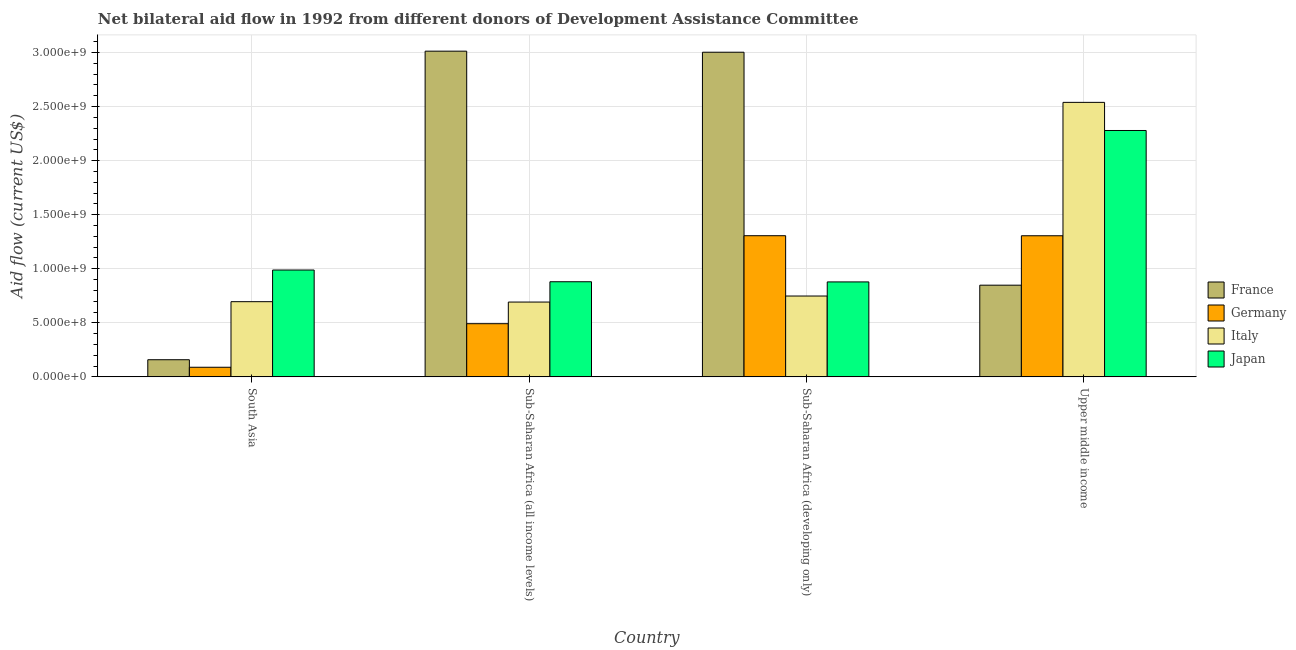How many different coloured bars are there?
Ensure brevity in your answer.  4. How many groups of bars are there?
Your response must be concise. 4. How many bars are there on the 3rd tick from the left?
Provide a short and direct response. 4. What is the label of the 2nd group of bars from the left?
Ensure brevity in your answer.  Sub-Saharan Africa (all income levels). What is the amount of aid given by italy in Sub-Saharan Africa (all income levels)?
Provide a short and direct response. 6.92e+08. Across all countries, what is the maximum amount of aid given by italy?
Offer a terse response. 2.54e+09. Across all countries, what is the minimum amount of aid given by germany?
Your answer should be compact. 8.89e+07. In which country was the amount of aid given by germany maximum?
Give a very brief answer. Sub-Saharan Africa (developing only). In which country was the amount of aid given by japan minimum?
Make the answer very short. Sub-Saharan Africa (developing only). What is the total amount of aid given by japan in the graph?
Offer a terse response. 5.03e+09. What is the difference between the amount of aid given by italy in Sub-Saharan Africa (all income levels) and that in Upper middle income?
Provide a short and direct response. -1.85e+09. What is the difference between the amount of aid given by germany in Upper middle income and the amount of aid given by france in South Asia?
Provide a succinct answer. 1.15e+09. What is the average amount of aid given by france per country?
Your response must be concise. 1.76e+09. What is the difference between the amount of aid given by italy and amount of aid given by france in Sub-Saharan Africa (all income levels)?
Keep it short and to the point. -2.32e+09. In how many countries, is the amount of aid given by italy greater than 2800000000 US$?
Provide a short and direct response. 0. What is the ratio of the amount of aid given by france in Sub-Saharan Africa (developing only) to that in Upper middle income?
Keep it short and to the point. 3.54. Is the amount of aid given by italy in Sub-Saharan Africa (all income levels) less than that in Upper middle income?
Provide a short and direct response. Yes. Is the difference between the amount of aid given by germany in Sub-Saharan Africa (developing only) and Upper middle income greater than the difference between the amount of aid given by italy in Sub-Saharan Africa (developing only) and Upper middle income?
Provide a succinct answer. Yes. What is the difference between the highest and the second highest amount of aid given by japan?
Give a very brief answer. 1.29e+09. What is the difference between the highest and the lowest amount of aid given by germany?
Ensure brevity in your answer.  1.22e+09. In how many countries, is the amount of aid given by japan greater than the average amount of aid given by japan taken over all countries?
Ensure brevity in your answer.  1. What does the 2nd bar from the right in Upper middle income represents?
Provide a succinct answer. Italy. Is it the case that in every country, the sum of the amount of aid given by france and amount of aid given by germany is greater than the amount of aid given by italy?
Offer a very short reply. No. How many bars are there?
Make the answer very short. 16. Are all the bars in the graph horizontal?
Offer a very short reply. No. What is the difference between two consecutive major ticks on the Y-axis?
Offer a very short reply. 5.00e+08. Are the values on the major ticks of Y-axis written in scientific E-notation?
Ensure brevity in your answer.  Yes. Does the graph contain grids?
Your response must be concise. Yes. How many legend labels are there?
Your answer should be compact. 4. What is the title of the graph?
Your response must be concise. Net bilateral aid flow in 1992 from different donors of Development Assistance Committee. Does "Primary" appear as one of the legend labels in the graph?
Your answer should be very brief. No. What is the label or title of the X-axis?
Provide a short and direct response. Country. What is the Aid flow (current US$) in France in South Asia?
Give a very brief answer. 1.59e+08. What is the Aid flow (current US$) in Germany in South Asia?
Provide a succinct answer. 8.89e+07. What is the Aid flow (current US$) of Italy in South Asia?
Make the answer very short. 6.95e+08. What is the Aid flow (current US$) in Japan in South Asia?
Ensure brevity in your answer.  9.88e+08. What is the Aid flow (current US$) of France in Sub-Saharan Africa (all income levels)?
Offer a terse response. 3.01e+09. What is the Aid flow (current US$) of Germany in Sub-Saharan Africa (all income levels)?
Provide a succinct answer. 4.92e+08. What is the Aid flow (current US$) in Italy in Sub-Saharan Africa (all income levels)?
Your answer should be compact. 6.92e+08. What is the Aid flow (current US$) in Japan in Sub-Saharan Africa (all income levels)?
Ensure brevity in your answer.  8.80e+08. What is the Aid flow (current US$) of France in Sub-Saharan Africa (developing only)?
Offer a very short reply. 3.00e+09. What is the Aid flow (current US$) of Germany in Sub-Saharan Africa (developing only)?
Give a very brief answer. 1.31e+09. What is the Aid flow (current US$) in Italy in Sub-Saharan Africa (developing only)?
Provide a short and direct response. 7.48e+08. What is the Aid flow (current US$) in Japan in Sub-Saharan Africa (developing only)?
Offer a terse response. 8.78e+08. What is the Aid flow (current US$) in France in Upper middle income?
Provide a succinct answer. 8.48e+08. What is the Aid flow (current US$) in Germany in Upper middle income?
Your answer should be very brief. 1.31e+09. What is the Aid flow (current US$) in Italy in Upper middle income?
Keep it short and to the point. 2.54e+09. What is the Aid flow (current US$) in Japan in Upper middle income?
Give a very brief answer. 2.28e+09. Across all countries, what is the maximum Aid flow (current US$) of France?
Keep it short and to the point. 3.01e+09. Across all countries, what is the maximum Aid flow (current US$) of Germany?
Your answer should be very brief. 1.31e+09. Across all countries, what is the maximum Aid flow (current US$) in Italy?
Ensure brevity in your answer.  2.54e+09. Across all countries, what is the maximum Aid flow (current US$) of Japan?
Provide a short and direct response. 2.28e+09. Across all countries, what is the minimum Aid flow (current US$) of France?
Your answer should be compact. 1.59e+08. Across all countries, what is the minimum Aid flow (current US$) in Germany?
Ensure brevity in your answer.  8.89e+07. Across all countries, what is the minimum Aid flow (current US$) in Italy?
Offer a terse response. 6.92e+08. Across all countries, what is the minimum Aid flow (current US$) in Japan?
Provide a short and direct response. 8.78e+08. What is the total Aid flow (current US$) in France in the graph?
Offer a terse response. 7.02e+09. What is the total Aid flow (current US$) in Germany in the graph?
Ensure brevity in your answer.  3.19e+09. What is the total Aid flow (current US$) in Italy in the graph?
Provide a short and direct response. 4.67e+09. What is the total Aid flow (current US$) of Japan in the graph?
Ensure brevity in your answer.  5.03e+09. What is the difference between the Aid flow (current US$) of France in South Asia and that in Sub-Saharan Africa (all income levels)?
Offer a very short reply. -2.85e+09. What is the difference between the Aid flow (current US$) in Germany in South Asia and that in Sub-Saharan Africa (all income levels)?
Offer a terse response. -4.03e+08. What is the difference between the Aid flow (current US$) in Italy in South Asia and that in Sub-Saharan Africa (all income levels)?
Give a very brief answer. 3.39e+06. What is the difference between the Aid flow (current US$) of Japan in South Asia and that in Sub-Saharan Africa (all income levels)?
Your response must be concise. 1.08e+08. What is the difference between the Aid flow (current US$) of France in South Asia and that in Sub-Saharan Africa (developing only)?
Ensure brevity in your answer.  -2.84e+09. What is the difference between the Aid flow (current US$) in Germany in South Asia and that in Sub-Saharan Africa (developing only)?
Keep it short and to the point. -1.22e+09. What is the difference between the Aid flow (current US$) in Italy in South Asia and that in Sub-Saharan Africa (developing only)?
Ensure brevity in your answer.  -5.24e+07. What is the difference between the Aid flow (current US$) of Japan in South Asia and that in Sub-Saharan Africa (developing only)?
Provide a succinct answer. 1.10e+08. What is the difference between the Aid flow (current US$) of France in South Asia and that in Upper middle income?
Your answer should be very brief. -6.89e+08. What is the difference between the Aid flow (current US$) in Germany in South Asia and that in Upper middle income?
Make the answer very short. -1.22e+09. What is the difference between the Aid flow (current US$) of Italy in South Asia and that in Upper middle income?
Ensure brevity in your answer.  -1.84e+09. What is the difference between the Aid flow (current US$) of Japan in South Asia and that in Upper middle income?
Keep it short and to the point. -1.29e+09. What is the difference between the Aid flow (current US$) of France in Sub-Saharan Africa (all income levels) and that in Sub-Saharan Africa (developing only)?
Offer a terse response. 9.93e+06. What is the difference between the Aid flow (current US$) in Germany in Sub-Saharan Africa (all income levels) and that in Sub-Saharan Africa (developing only)?
Your answer should be compact. -8.14e+08. What is the difference between the Aid flow (current US$) of Italy in Sub-Saharan Africa (all income levels) and that in Sub-Saharan Africa (developing only)?
Ensure brevity in your answer.  -5.58e+07. What is the difference between the Aid flow (current US$) of Japan in Sub-Saharan Africa (all income levels) and that in Sub-Saharan Africa (developing only)?
Give a very brief answer. 1.49e+06. What is the difference between the Aid flow (current US$) in France in Sub-Saharan Africa (all income levels) and that in Upper middle income?
Your response must be concise. 2.16e+09. What is the difference between the Aid flow (current US$) of Germany in Sub-Saharan Africa (all income levels) and that in Upper middle income?
Give a very brief answer. -8.13e+08. What is the difference between the Aid flow (current US$) of Italy in Sub-Saharan Africa (all income levels) and that in Upper middle income?
Offer a very short reply. -1.85e+09. What is the difference between the Aid flow (current US$) of Japan in Sub-Saharan Africa (all income levels) and that in Upper middle income?
Make the answer very short. -1.40e+09. What is the difference between the Aid flow (current US$) in France in Sub-Saharan Africa (developing only) and that in Upper middle income?
Ensure brevity in your answer.  2.15e+09. What is the difference between the Aid flow (current US$) in Italy in Sub-Saharan Africa (developing only) and that in Upper middle income?
Make the answer very short. -1.79e+09. What is the difference between the Aid flow (current US$) in Japan in Sub-Saharan Africa (developing only) and that in Upper middle income?
Keep it short and to the point. -1.40e+09. What is the difference between the Aid flow (current US$) of France in South Asia and the Aid flow (current US$) of Germany in Sub-Saharan Africa (all income levels)?
Provide a short and direct response. -3.33e+08. What is the difference between the Aid flow (current US$) in France in South Asia and the Aid flow (current US$) in Italy in Sub-Saharan Africa (all income levels)?
Ensure brevity in your answer.  -5.33e+08. What is the difference between the Aid flow (current US$) in France in South Asia and the Aid flow (current US$) in Japan in Sub-Saharan Africa (all income levels)?
Give a very brief answer. -7.21e+08. What is the difference between the Aid flow (current US$) in Germany in South Asia and the Aid flow (current US$) in Italy in Sub-Saharan Africa (all income levels)?
Your answer should be very brief. -6.03e+08. What is the difference between the Aid flow (current US$) of Germany in South Asia and the Aid flow (current US$) of Japan in Sub-Saharan Africa (all income levels)?
Make the answer very short. -7.91e+08. What is the difference between the Aid flow (current US$) in Italy in South Asia and the Aid flow (current US$) in Japan in Sub-Saharan Africa (all income levels)?
Provide a short and direct response. -1.84e+08. What is the difference between the Aid flow (current US$) of France in South Asia and the Aid flow (current US$) of Germany in Sub-Saharan Africa (developing only)?
Give a very brief answer. -1.15e+09. What is the difference between the Aid flow (current US$) of France in South Asia and the Aid flow (current US$) of Italy in Sub-Saharan Africa (developing only)?
Provide a succinct answer. -5.89e+08. What is the difference between the Aid flow (current US$) of France in South Asia and the Aid flow (current US$) of Japan in Sub-Saharan Africa (developing only)?
Provide a succinct answer. -7.20e+08. What is the difference between the Aid flow (current US$) of Germany in South Asia and the Aid flow (current US$) of Italy in Sub-Saharan Africa (developing only)?
Ensure brevity in your answer.  -6.59e+08. What is the difference between the Aid flow (current US$) in Germany in South Asia and the Aid flow (current US$) in Japan in Sub-Saharan Africa (developing only)?
Give a very brief answer. -7.90e+08. What is the difference between the Aid flow (current US$) in Italy in South Asia and the Aid flow (current US$) in Japan in Sub-Saharan Africa (developing only)?
Offer a very short reply. -1.83e+08. What is the difference between the Aid flow (current US$) of France in South Asia and the Aid flow (current US$) of Germany in Upper middle income?
Offer a terse response. -1.15e+09. What is the difference between the Aid flow (current US$) of France in South Asia and the Aid flow (current US$) of Italy in Upper middle income?
Offer a terse response. -2.38e+09. What is the difference between the Aid flow (current US$) of France in South Asia and the Aid flow (current US$) of Japan in Upper middle income?
Provide a succinct answer. -2.12e+09. What is the difference between the Aid flow (current US$) in Germany in South Asia and the Aid flow (current US$) in Italy in Upper middle income?
Offer a terse response. -2.45e+09. What is the difference between the Aid flow (current US$) in Germany in South Asia and the Aid flow (current US$) in Japan in Upper middle income?
Keep it short and to the point. -2.19e+09. What is the difference between the Aid flow (current US$) in Italy in South Asia and the Aid flow (current US$) in Japan in Upper middle income?
Ensure brevity in your answer.  -1.58e+09. What is the difference between the Aid flow (current US$) in France in Sub-Saharan Africa (all income levels) and the Aid flow (current US$) in Germany in Sub-Saharan Africa (developing only)?
Ensure brevity in your answer.  1.71e+09. What is the difference between the Aid flow (current US$) of France in Sub-Saharan Africa (all income levels) and the Aid flow (current US$) of Italy in Sub-Saharan Africa (developing only)?
Your answer should be very brief. 2.26e+09. What is the difference between the Aid flow (current US$) in France in Sub-Saharan Africa (all income levels) and the Aid flow (current US$) in Japan in Sub-Saharan Africa (developing only)?
Offer a terse response. 2.13e+09. What is the difference between the Aid flow (current US$) of Germany in Sub-Saharan Africa (all income levels) and the Aid flow (current US$) of Italy in Sub-Saharan Africa (developing only)?
Provide a short and direct response. -2.56e+08. What is the difference between the Aid flow (current US$) of Germany in Sub-Saharan Africa (all income levels) and the Aid flow (current US$) of Japan in Sub-Saharan Africa (developing only)?
Give a very brief answer. -3.86e+08. What is the difference between the Aid flow (current US$) in Italy in Sub-Saharan Africa (all income levels) and the Aid flow (current US$) in Japan in Sub-Saharan Africa (developing only)?
Offer a terse response. -1.86e+08. What is the difference between the Aid flow (current US$) in France in Sub-Saharan Africa (all income levels) and the Aid flow (current US$) in Germany in Upper middle income?
Your answer should be compact. 1.71e+09. What is the difference between the Aid flow (current US$) of France in Sub-Saharan Africa (all income levels) and the Aid flow (current US$) of Italy in Upper middle income?
Your answer should be very brief. 4.74e+08. What is the difference between the Aid flow (current US$) of France in Sub-Saharan Africa (all income levels) and the Aid flow (current US$) of Japan in Upper middle income?
Offer a terse response. 7.34e+08. What is the difference between the Aid flow (current US$) of Germany in Sub-Saharan Africa (all income levels) and the Aid flow (current US$) of Italy in Upper middle income?
Your answer should be compact. -2.05e+09. What is the difference between the Aid flow (current US$) in Germany in Sub-Saharan Africa (all income levels) and the Aid flow (current US$) in Japan in Upper middle income?
Give a very brief answer. -1.79e+09. What is the difference between the Aid flow (current US$) of Italy in Sub-Saharan Africa (all income levels) and the Aid flow (current US$) of Japan in Upper middle income?
Keep it short and to the point. -1.59e+09. What is the difference between the Aid flow (current US$) in France in Sub-Saharan Africa (developing only) and the Aid flow (current US$) in Germany in Upper middle income?
Provide a short and direct response. 1.70e+09. What is the difference between the Aid flow (current US$) in France in Sub-Saharan Africa (developing only) and the Aid flow (current US$) in Italy in Upper middle income?
Ensure brevity in your answer.  4.64e+08. What is the difference between the Aid flow (current US$) of France in Sub-Saharan Africa (developing only) and the Aid flow (current US$) of Japan in Upper middle income?
Offer a terse response. 7.24e+08. What is the difference between the Aid flow (current US$) in Germany in Sub-Saharan Africa (developing only) and the Aid flow (current US$) in Italy in Upper middle income?
Your answer should be very brief. -1.23e+09. What is the difference between the Aid flow (current US$) of Germany in Sub-Saharan Africa (developing only) and the Aid flow (current US$) of Japan in Upper middle income?
Ensure brevity in your answer.  -9.73e+08. What is the difference between the Aid flow (current US$) of Italy in Sub-Saharan Africa (developing only) and the Aid flow (current US$) of Japan in Upper middle income?
Offer a terse response. -1.53e+09. What is the average Aid flow (current US$) of France per country?
Provide a succinct answer. 1.76e+09. What is the average Aid flow (current US$) of Germany per country?
Your response must be concise. 7.98e+08. What is the average Aid flow (current US$) of Italy per country?
Your answer should be very brief. 1.17e+09. What is the average Aid flow (current US$) of Japan per country?
Provide a short and direct response. 1.26e+09. What is the difference between the Aid flow (current US$) in France and Aid flow (current US$) in Germany in South Asia?
Your answer should be compact. 6.97e+07. What is the difference between the Aid flow (current US$) of France and Aid flow (current US$) of Italy in South Asia?
Your answer should be compact. -5.37e+08. What is the difference between the Aid flow (current US$) of France and Aid flow (current US$) of Japan in South Asia?
Offer a very short reply. -8.30e+08. What is the difference between the Aid flow (current US$) of Germany and Aid flow (current US$) of Italy in South Asia?
Offer a very short reply. -6.07e+08. What is the difference between the Aid flow (current US$) in Germany and Aid flow (current US$) in Japan in South Asia?
Provide a succinct answer. -8.99e+08. What is the difference between the Aid flow (current US$) of Italy and Aid flow (current US$) of Japan in South Asia?
Ensure brevity in your answer.  -2.93e+08. What is the difference between the Aid flow (current US$) in France and Aid flow (current US$) in Germany in Sub-Saharan Africa (all income levels)?
Keep it short and to the point. 2.52e+09. What is the difference between the Aid flow (current US$) of France and Aid flow (current US$) of Italy in Sub-Saharan Africa (all income levels)?
Provide a short and direct response. 2.32e+09. What is the difference between the Aid flow (current US$) in France and Aid flow (current US$) in Japan in Sub-Saharan Africa (all income levels)?
Ensure brevity in your answer.  2.13e+09. What is the difference between the Aid flow (current US$) of Germany and Aid flow (current US$) of Italy in Sub-Saharan Africa (all income levels)?
Your response must be concise. -2.00e+08. What is the difference between the Aid flow (current US$) in Germany and Aid flow (current US$) in Japan in Sub-Saharan Africa (all income levels)?
Give a very brief answer. -3.88e+08. What is the difference between the Aid flow (current US$) in Italy and Aid flow (current US$) in Japan in Sub-Saharan Africa (all income levels)?
Offer a terse response. -1.88e+08. What is the difference between the Aid flow (current US$) in France and Aid flow (current US$) in Germany in Sub-Saharan Africa (developing only)?
Your answer should be compact. 1.70e+09. What is the difference between the Aid flow (current US$) of France and Aid flow (current US$) of Italy in Sub-Saharan Africa (developing only)?
Provide a short and direct response. 2.25e+09. What is the difference between the Aid flow (current US$) of France and Aid flow (current US$) of Japan in Sub-Saharan Africa (developing only)?
Offer a terse response. 2.12e+09. What is the difference between the Aid flow (current US$) of Germany and Aid flow (current US$) of Italy in Sub-Saharan Africa (developing only)?
Make the answer very short. 5.58e+08. What is the difference between the Aid flow (current US$) of Germany and Aid flow (current US$) of Japan in Sub-Saharan Africa (developing only)?
Offer a terse response. 4.27e+08. What is the difference between the Aid flow (current US$) of Italy and Aid flow (current US$) of Japan in Sub-Saharan Africa (developing only)?
Your response must be concise. -1.30e+08. What is the difference between the Aid flow (current US$) of France and Aid flow (current US$) of Germany in Upper middle income?
Provide a short and direct response. -4.57e+08. What is the difference between the Aid flow (current US$) of France and Aid flow (current US$) of Italy in Upper middle income?
Give a very brief answer. -1.69e+09. What is the difference between the Aid flow (current US$) of France and Aid flow (current US$) of Japan in Upper middle income?
Give a very brief answer. -1.43e+09. What is the difference between the Aid flow (current US$) in Germany and Aid flow (current US$) in Italy in Upper middle income?
Your answer should be compact. -1.23e+09. What is the difference between the Aid flow (current US$) in Germany and Aid flow (current US$) in Japan in Upper middle income?
Offer a very short reply. -9.74e+08. What is the difference between the Aid flow (current US$) of Italy and Aid flow (current US$) of Japan in Upper middle income?
Provide a short and direct response. 2.60e+08. What is the ratio of the Aid flow (current US$) of France in South Asia to that in Sub-Saharan Africa (all income levels)?
Your answer should be very brief. 0.05. What is the ratio of the Aid flow (current US$) of Germany in South Asia to that in Sub-Saharan Africa (all income levels)?
Ensure brevity in your answer.  0.18. What is the ratio of the Aid flow (current US$) of Italy in South Asia to that in Sub-Saharan Africa (all income levels)?
Make the answer very short. 1. What is the ratio of the Aid flow (current US$) in Japan in South Asia to that in Sub-Saharan Africa (all income levels)?
Make the answer very short. 1.12. What is the ratio of the Aid flow (current US$) in France in South Asia to that in Sub-Saharan Africa (developing only)?
Ensure brevity in your answer.  0.05. What is the ratio of the Aid flow (current US$) of Germany in South Asia to that in Sub-Saharan Africa (developing only)?
Your answer should be compact. 0.07. What is the ratio of the Aid flow (current US$) in Italy in South Asia to that in Sub-Saharan Africa (developing only)?
Give a very brief answer. 0.93. What is the ratio of the Aid flow (current US$) of Japan in South Asia to that in Sub-Saharan Africa (developing only)?
Provide a short and direct response. 1.13. What is the ratio of the Aid flow (current US$) in France in South Asia to that in Upper middle income?
Offer a very short reply. 0.19. What is the ratio of the Aid flow (current US$) of Germany in South Asia to that in Upper middle income?
Ensure brevity in your answer.  0.07. What is the ratio of the Aid flow (current US$) of Italy in South Asia to that in Upper middle income?
Provide a short and direct response. 0.27. What is the ratio of the Aid flow (current US$) of Japan in South Asia to that in Upper middle income?
Your answer should be very brief. 0.43. What is the ratio of the Aid flow (current US$) of Germany in Sub-Saharan Africa (all income levels) to that in Sub-Saharan Africa (developing only)?
Provide a short and direct response. 0.38. What is the ratio of the Aid flow (current US$) in Italy in Sub-Saharan Africa (all income levels) to that in Sub-Saharan Africa (developing only)?
Offer a terse response. 0.93. What is the ratio of the Aid flow (current US$) in France in Sub-Saharan Africa (all income levels) to that in Upper middle income?
Provide a succinct answer. 3.55. What is the ratio of the Aid flow (current US$) in Germany in Sub-Saharan Africa (all income levels) to that in Upper middle income?
Keep it short and to the point. 0.38. What is the ratio of the Aid flow (current US$) in Italy in Sub-Saharan Africa (all income levels) to that in Upper middle income?
Your answer should be compact. 0.27. What is the ratio of the Aid flow (current US$) in Japan in Sub-Saharan Africa (all income levels) to that in Upper middle income?
Offer a terse response. 0.39. What is the ratio of the Aid flow (current US$) of France in Sub-Saharan Africa (developing only) to that in Upper middle income?
Your answer should be very brief. 3.54. What is the ratio of the Aid flow (current US$) of Italy in Sub-Saharan Africa (developing only) to that in Upper middle income?
Keep it short and to the point. 0.29. What is the ratio of the Aid flow (current US$) in Japan in Sub-Saharan Africa (developing only) to that in Upper middle income?
Keep it short and to the point. 0.39. What is the difference between the highest and the second highest Aid flow (current US$) in France?
Offer a terse response. 9.93e+06. What is the difference between the highest and the second highest Aid flow (current US$) in Germany?
Make the answer very short. 4.50e+05. What is the difference between the highest and the second highest Aid flow (current US$) in Italy?
Your answer should be very brief. 1.79e+09. What is the difference between the highest and the second highest Aid flow (current US$) in Japan?
Provide a short and direct response. 1.29e+09. What is the difference between the highest and the lowest Aid flow (current US$) in France?
Ensure brevity in your answer.  2.85e+09. What is the difference between the highest and the lowest Aid flow (current US$) in Germany?
Offer a terse response. 1.22e+09. What is the difference between the highest and the lowest Aid flow (current US$) of Italy?
Make the answer very short. 1.85e+09. What is the difference between the highest and the lowest Aid flow (current US$) in Japan?
Your response must be concise. 1.40e+09. 